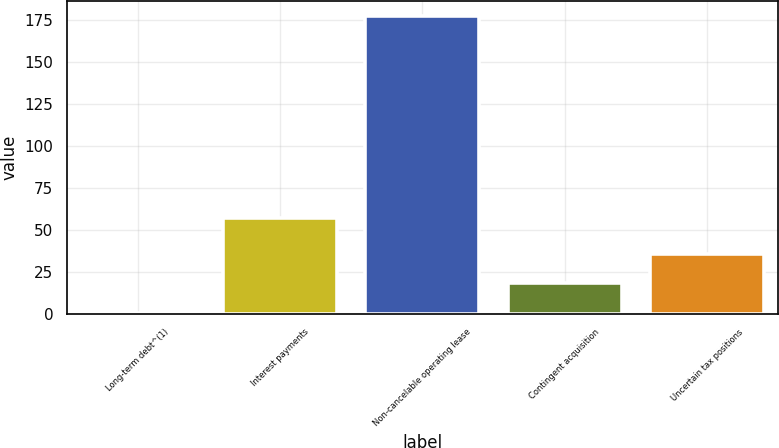Convert chart. <chart><loc_0><loc_0><loc_500><loc_500><bar_chart><fcel>Long-term debt^(1)<fcel>Interest payments<fcel>Non-cancelable operating lease<fcel>Contingent acquisition<fcel>Uncertain tax positions<nl><fcel>0.7<fcel>57.4<fcel>177.7<fcel>18.4<fcel>36.1<nl></chart> 